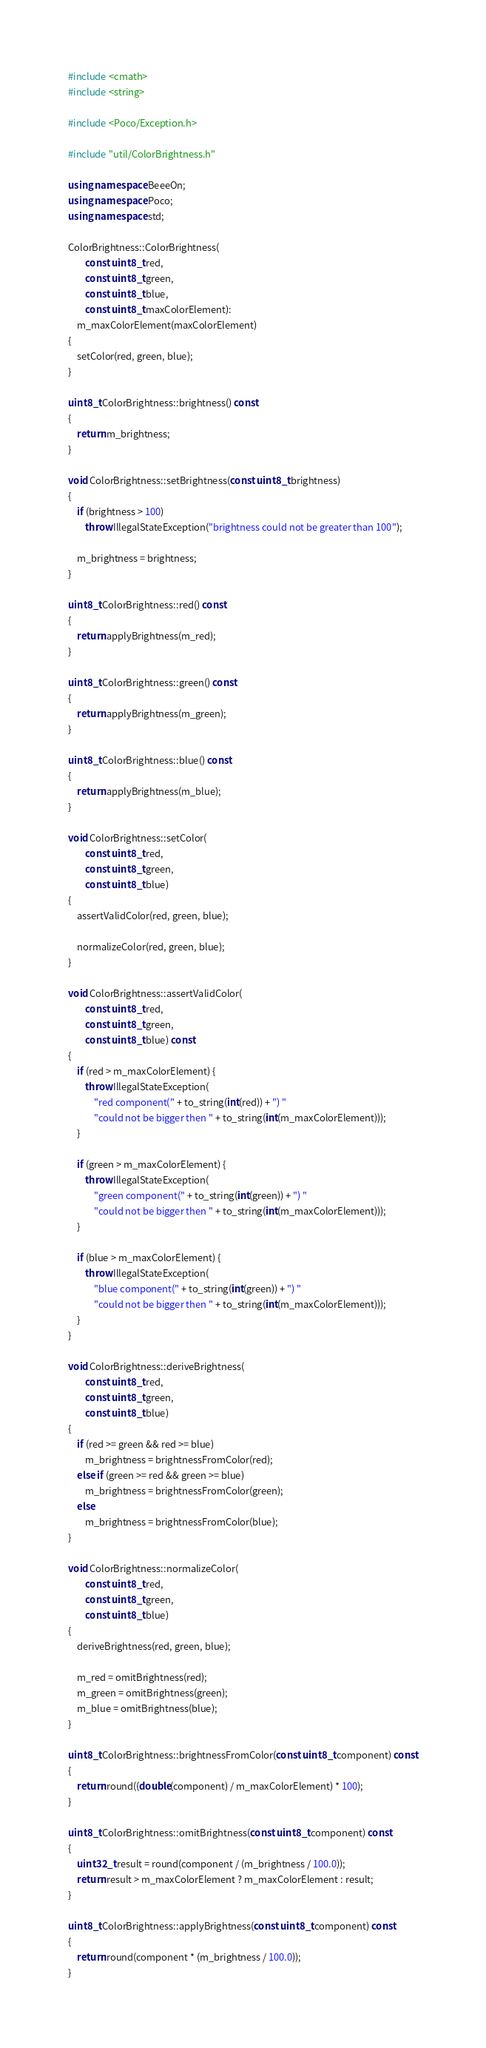<code> <loc_0><loc_0><loc_500><loc_500><_C++_>#include <cmath>
#include <string>

#include <Poco/Exception.h>

#include "util/ColorBrightness.h"

using namespace BeeeOn;
using namespace Poco;
using namespace std;

ColorBrightness::ColorBrightness(
		const uint8_t red,
		const uint8_t green,
		const uint8_t blue,
		const uint8_t maxColorElement):
	m_maxColorElement(maxColorElement)
{
	setColor(red, green, blue);
}

uint8_t ColorBrightness::brightness() const
{
	return m_brightness;
}

void ColorBrightness::setBrightness(const uint8_t brightness)
{
	if (brightness > 100)
		throw IllegalStateException("brightness could not be greater than 100");

	m_brightness = brightness;
}

uint8_t ColorBrightness::red() const
{
	return applyBrightness(m_red);
}

uint8_t ColorBrightness::green() const
{
	return applyBrightness(m_green);
}

uint8_t ColorBrightness::blue() const
{
	return applyBrightness(m_blue);
}

void ColorBrightness::setColor(
		const uint8_t red,
		const uint8_t green,
		const uint8_t blue)
{
	assertValidColor(red, green, blue);

	normalizeColor(red, green, blue);
}

void ColorBrightness::assertValidColor(
		const uint8_t red,
		const uint8_t green,
		const uint8_t blue) const
{
	if (red > m_maxColorElement) {
		throw IllegalStateException(
			"red component(" + to_string(int(red)) + ") "
			"could not be bigger then " + to_string(int(m_maxColorElement)));
	}

	if (green > m_maxColorElement) {
		throw IllegalStateException(
			"green component(" + to_string(int(green)) + ") "
			"could not be bigger then " + to_string(int(m_maxColorElement)));
	}

	if (blue > m_maxColorElement) {
		throw IllegalStateException(
			"blue component(" + to_string(int(green)) + ") "
			"could not be bigger then " + to_string(int(m_maxColorElement)));
	}
}

void ColorBrightness::deriveBrightness(
		const uint8_t red,
		const uint8_t green,
		const uint8_t blue)
{
	if (red >= green && red >= blue)
		m_brightness = brightnessFromColor(red);
	else if (green >= red && green >= blue)
		m_brightness = brightnessFromColor(green);
	else
		m_brightness = brightnessFromColor(blue);
}

void ColorBrightness::normalizeColor(
		const uint8_t red,
		const uint8_t green,
		const uint8_t blue)
{
	deriveBrightness(red, green, blue);

	m_red = omitBrightness(red);
	m_green = omitBrightness(green);
	m_blue = omitBrightness(blue);
}

uint8_t ColorBrightness::brightnessFromColor(const uint8_t component) const
{
	return round((double(component) / m_maxColorElement) * 100);
}

uint8_t ColorBrightness::omitBrightness(const uint8_t component) const
{
	uint32_t result = round(component / (m_brightness / 100.0));
	return result > m_maxColorElement ? m_maxColorElement : result;
}

uint8_t ColorBrightness::applyBrightness(const uint8_t component) const
{
	return round(component * (m_brightness / 100.0));
}
</code> 